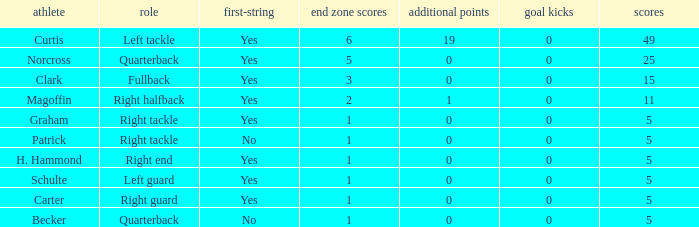Name the number of field goals for 19 extra points 1.0. 